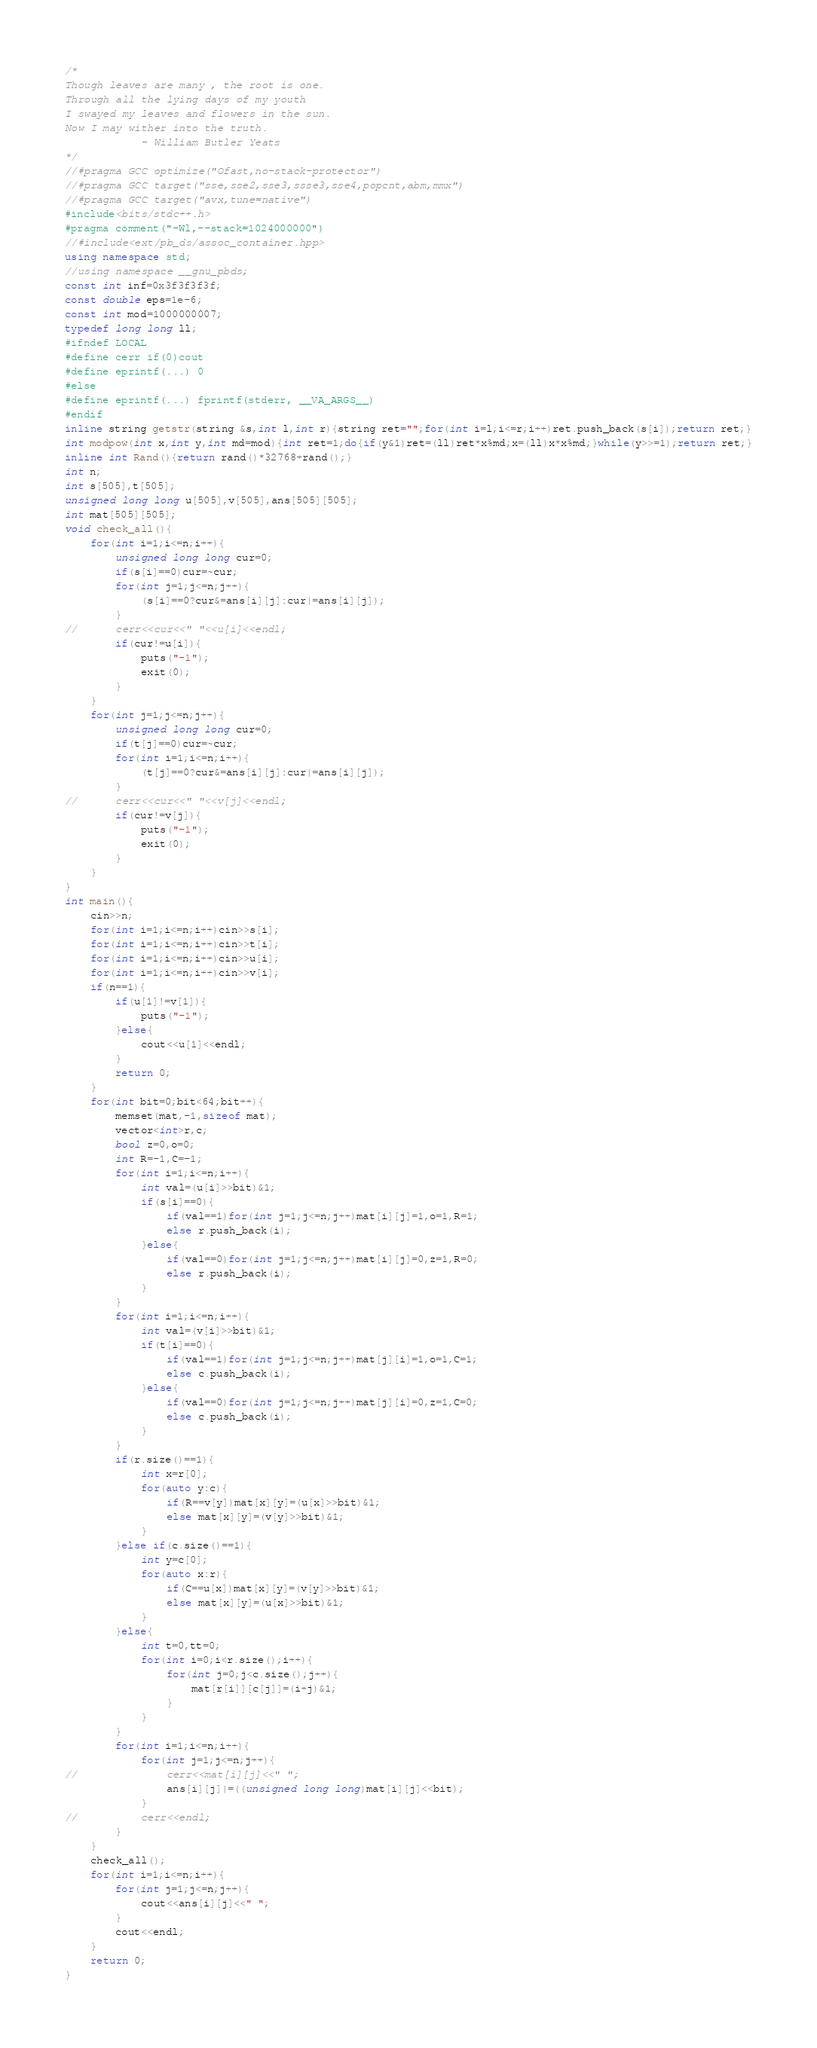Convert code to text. <code><loc_0><loc_0><loc_500><loc_500><_C++_>/*
Though leaves are many , the root is one.
Through all the lying days of my youth
I swayed my leaves and flowers in the sun.
Now I may wither into the truth.
	  	  	- William Butler Yeats
*/
//#pragma GCC optimize("Ofast,no-stack-protector")
//#pragma GCC target("sse,sse2,sse3,ssse3,sse4,popcnt,abm,mmx")
//#pragma GCC target("avx,tune=native")
#include<bits/stdc++.h>
#pragma comment("-Wl,--stack=1024000000")
//#include<ext/pb_ds/assoc_container.hpp>
using namespace std;
//using namespace __gnu_pbds;
const int inf=0x3f3f3f3f;
const double eps=1e-6;
const int mod=1000000007;
typedef long long ll;
#ifndef LOCAL
#define cerr if(0)cout
#define eprintf(...) 0
#else
#define eprintf(...) fprintf(stderr, __VA_ARGS__)
#endif
inline string getstr(string &s,int l,int r){string ret="";for(int i=l;i<=r;i++)ret.push_back(s[i]);return ret;}
int modpow(int x,int y,int md=mod){int ret=1;do{if(y&1)ret=(ll)ret*x%md;x=(ll)x*x%md;}while(y>>=1);return ret;}
inline int Rand(){return rand()*32768+rand();}
int n;
int s[505],t[505];
unsigned long long u[505],v[505],ans[505][505];
int mat[505][505];
void check_all(){
	for(int i=1;i<=n;i++){
		unsigned long long cur=0;
		if(s[i]==0)cur=~cur;
		for(int j=1;j<=n;j++){
			(s[i]==0?cur&=ans[i][j]:cur|=ans[i][j]);
		}
//		cerr<<cur<<" "<<u[i]<<endl;
		if(cur!=u[i]){
			puts("-1");
			exit(0);
		}
	}
	for(int j=1;j<=n;j++){
		unsigned long long cur=0;
		if(t[j]==0)cur=~cur;
		for(int i=1;i<=n;i++){
			(t[j]==0?cur&=ans[i][j]:cur|=ans[i][j]);
		}
//		cerr<<cur<<" "<<v[j]<<endl;
		if(cur!=v[j]){
			puts("-1");
			exit(0);
		}
	}
}
int main(){
	cin>>n;
	for(int i=1;i<=n;i++)cin>>s[i];
	for(int i=1;i<=n;i++)cin>>t[i];
	for(int i=1;i<=n;i++)cin>>u[i];
	for(int i=1;i<=n;i++)cin>>v[i];
	if(n==1){
		if(u[1]!=v[1]){
			puts("-1");
		}else{
			cout<<u[1]<<endl;
		}
		return 0;
	}
	for(int bit=0;bit<64;bit++){
		memset(mat,-1,sizeof mat);
		vector<int>r,c;
		bool z=0,o=0;
		int R=-1,C=-1;
		for(int i=1;i<=n;i++){
			int val=(u[i]>>bit)&1;
			if(s[i]==0){
				if(val==1)for(int j=1;j<=n;j++)mat[i][j]=1,o=1,R=1;
				else r.push_back(i);
			}else{
				if(val==0)for(int j=1;j<=n;j++)mat[i][j]=0,z=1,R=0;
				else r.push_back(i);
			}
		}
		for(int i=1;i<=n;i++){
			int val=(v[i]>>bit)&1;
			if(t[i]==0){
				if(val==1)for(int j=1;j<=n;j++)mat[j][i]=1,o=1,C=1;
				else c.push_back(i);
			}else{
				if(val==0)for(int j=1;j<=n;j++)mat[j][i]=0,z=1,C=0;
				else c.push_back(i);
			}
		}
		if(r.size()==1){
			int x=r[0];
			for(auto y:c){
				if(R==v[y])mat[x][y]=(u[x]>>bit)&1;
				else mat[x][y]=(v[y]>>bit)&1;
			}
		}else if(c.size()==1){
			int y=c[0]; 
			for(auto x:r){
				if(C==u[x])mat[x][y]=(v[y]>>bit)&1;
				else mat[x][y]=(u[x]>>bit)&1;
			}
		}else{
			int t=0,tt=0;
			for(int i=0;i<r.size();i++){
				for(int j=0;j<c.size();j++){
					mat[r[i]][c[j]]=(i+j)&1;
				}
			}
		}
		for(int i=1;i<=n;i++){
			for(int j=1;j<=n;j++){
//				cerr<<mat[i][j]<<" ";
				ans[i][j]|=((unsigned long long)mat[i][j]<<bit);
			}
//			cerr<<endl;
		}
	}
	check_all();
	for(int i=1;i<=n;i++){
		for(int j=1;j<=n;j++){
			cout<<ans[i][j]<<" ";
		}
		cout<<endl;
	}
	return 0;
}</code> 